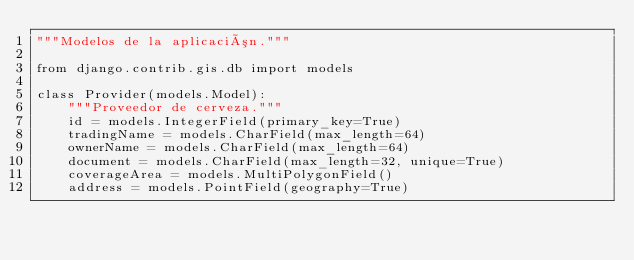Convert code to text. <code><loc_0><loc_0><loc_500><loc_500><_Python_>"""Modelos de la aplicación."""

from django.contrib.gis.db import models

class Provider(models.Model):
    """Proveedor de cerveza."""
    id = models.IntegerField(primary_key=True)
    tradingName = models.CharField(max_length=64)
    ownerName = models.CharField(max_length=64)
    document = models.CharField(max_length=32, unique=True)
    coverageArea = models.MultiPolygonField()
    address = models.PointField(geography=True)
</code> 